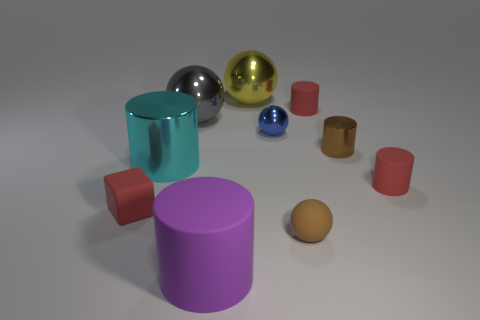Subtract 2 cylinders. How many cylinders are left? 3 Subtract all cyan cylinders. How many cylinders are left? 4 Subtract all small brown metallic cylinders. How many cylinders are left? 4 Subtract all gray cylinders. Subtract all green spheres. How many cylinders are left? 5 Subtract all spheres. How many objects are left? 6 Add 6 large yellow metallic objects. How many large yellow metallic objects are left? 7 Add 9 cyan objects. How many cyan objects exist? 10 Subtract 0 purple balls. How many objects are left? 10 Subtract all cyan cylinders. Subtract all cylinders. How many objects are left? 4 